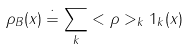<formula> <loc_0><loc_0><loc_500><loc_500>\rho _ { B } ( x ) \doteq \sum _ { k } < \rho > _ { k } 1 _ { k } ( x )</formula> 